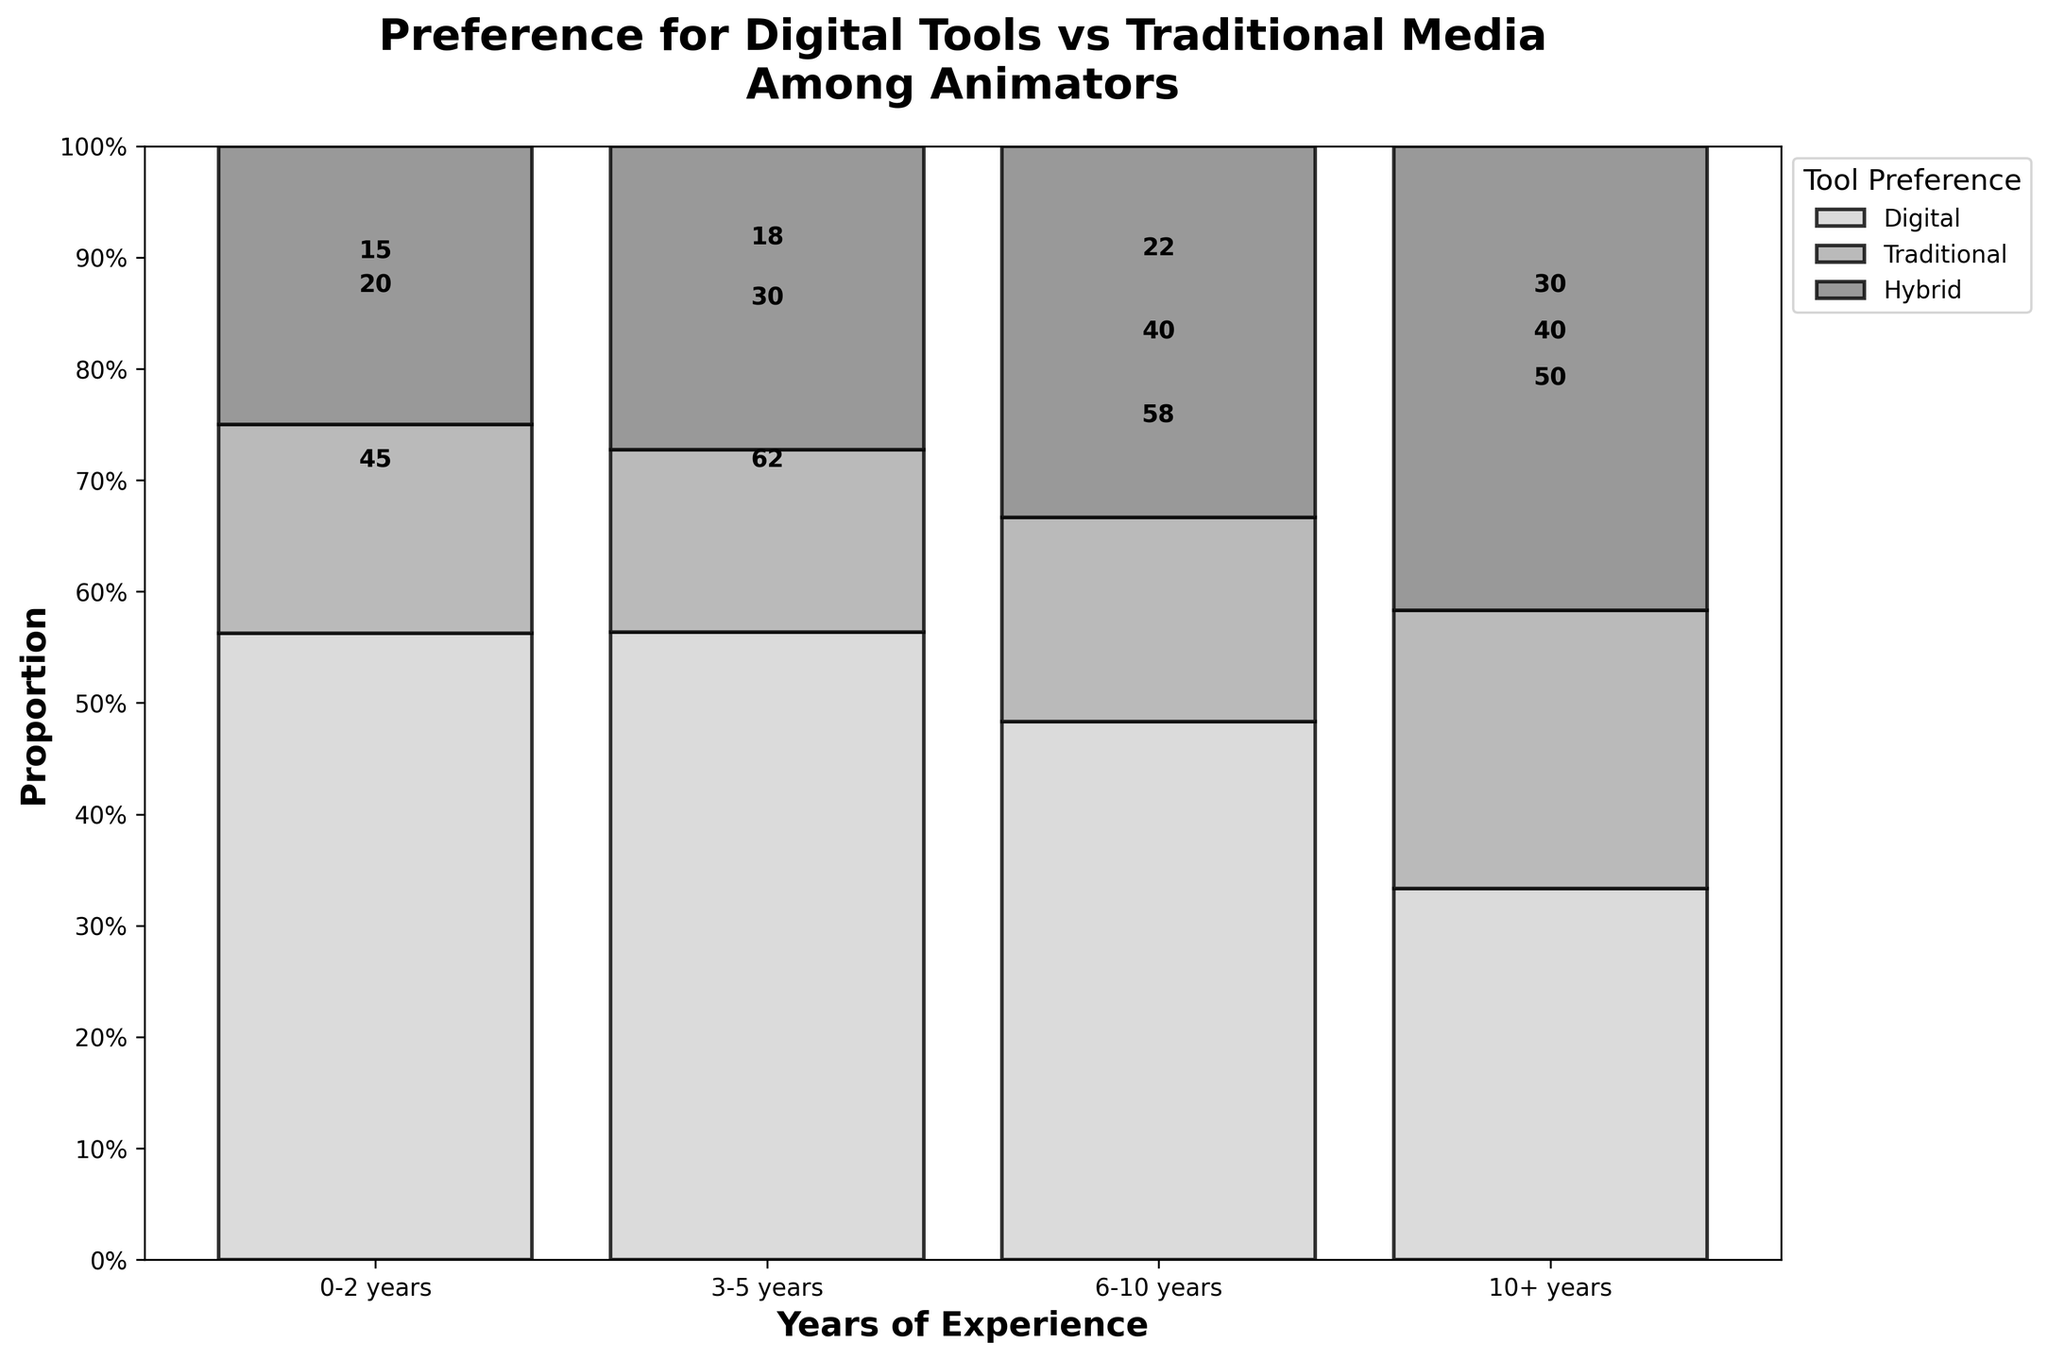How many distinct tool preferences are represented in the plot? There are three different tool preferences indicated by the legend at the top left of the plot. They are Digital, Traditional, and Hybrid.
Answer: 3 What color represents the 'Traditional' tool preference? According to the legend, the 'Traditional' tool preference is represented by the darkest shade of gray in the plot.
Answer: Darkest shade of gray Which tool preference is most popular among animators with 6-10 years of experience? By observing the bar corresponding to 6-10 years of experience, the 'Hybrid' segment is the largest, indicating it is the most popular among these animators.
Answer: Hybrid How many animators with 0-2 years of experience prefer Digital tools? By looking at the Digital section of the bar for 0-2 years, the number inside the segment is 45.
Answer: 45 What is the proportion of animators with 10+ years of experience who prefer Hybrid tools? The height of the Hybrid segment in the 10+ years bar covers the majority of the total height. With the total height being 100%, this is approximately 50%.
Answer: 50% Compare the preference for Traditional tools between animators with 0-2 years of experience and those with 10+ years of experience. The Traditional segment in the 0-2 years bar is smaller than in the 10+ years bar. The actual counts, as shown in the segments, are 15 for 0-2 years and 30 for 10+ years, making the latter larger.
Answer: 10+ years Which experience level shows the least preference for Digital tools? Among the four experience levels, the 10+ years bar has the smallest Digital segment, showing the least preference.
Answer: 10+ years Combine the total number of animators who prefer Traditional tools with 3-5 and 6-10 years of experience. Adding the counts for Traditional preference, 3-5 years have 18 animators and 6-10 years have 22 animators. So, 18 + 22 = 40.
Answer: 40 What is the combined proportion of Digital and Traditional tool preference among animators with 3-5 years of experience? The proportions of Digital and Traditional segments in the 3-5 years bar together cover a large part of the bar. Approximately, Digital is 62/(62 + 18 + 30) ≈ 56% and Traditional is 18/(62 + 18 + 30) ≈ 16%. So, 56% + 16% = 72%.
Answer: 72% Does the number of animators with 3-5 years of experience who prefer Hybrid tools exceed those with 0-2 years of experience? From the plot, the Hybrid segment of the bar for 3-5 years shows 30 animators compared to 20 for the 0-2 years segment. Therefore, 30 > 20.
Answer: Yes 